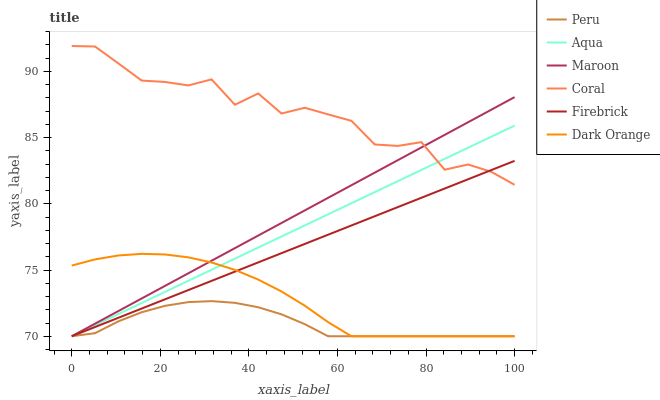Does Firebrick have the minimum area under the curve?
Answer yes or no. No. Does Firebrick have the maximum area under the curve?
Answer yes or no. No. Is Aqua the smoothest?
Answer yes or no. No. Is Aqua the roughest?
Answer yes or no. No. Does Coral have the lowest value?
Answer yes or no. No. Does Firebrick have the highest value?
Answer yes or no. No. Is Dark Orange less than Coral?
Answer yes or no. Yes. Is Coral greater than Peru?
Answer yes or no. Yes. Does Dark Orange intersect Coral?
Answer yes or no. No. 